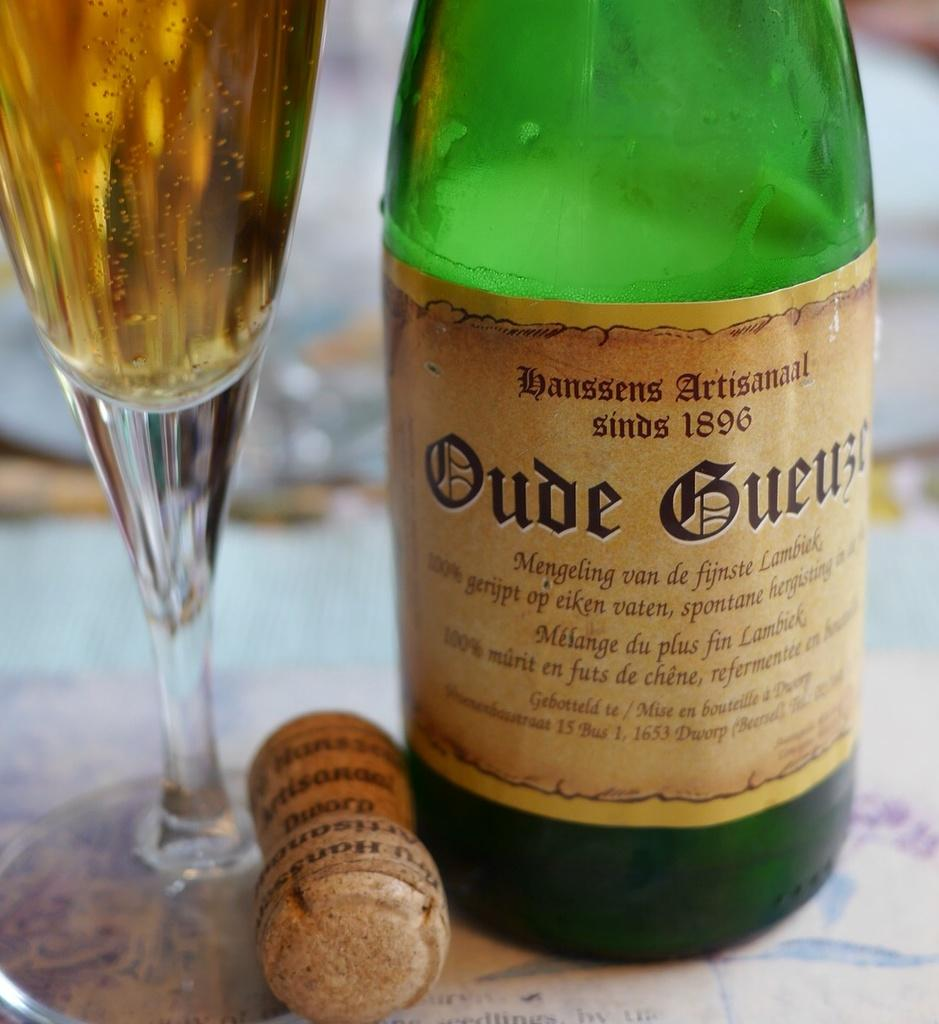<image>
Present a compact description of the photo's key features. A bottle of a drink with the date 1896 on the label sits next to its cork. 